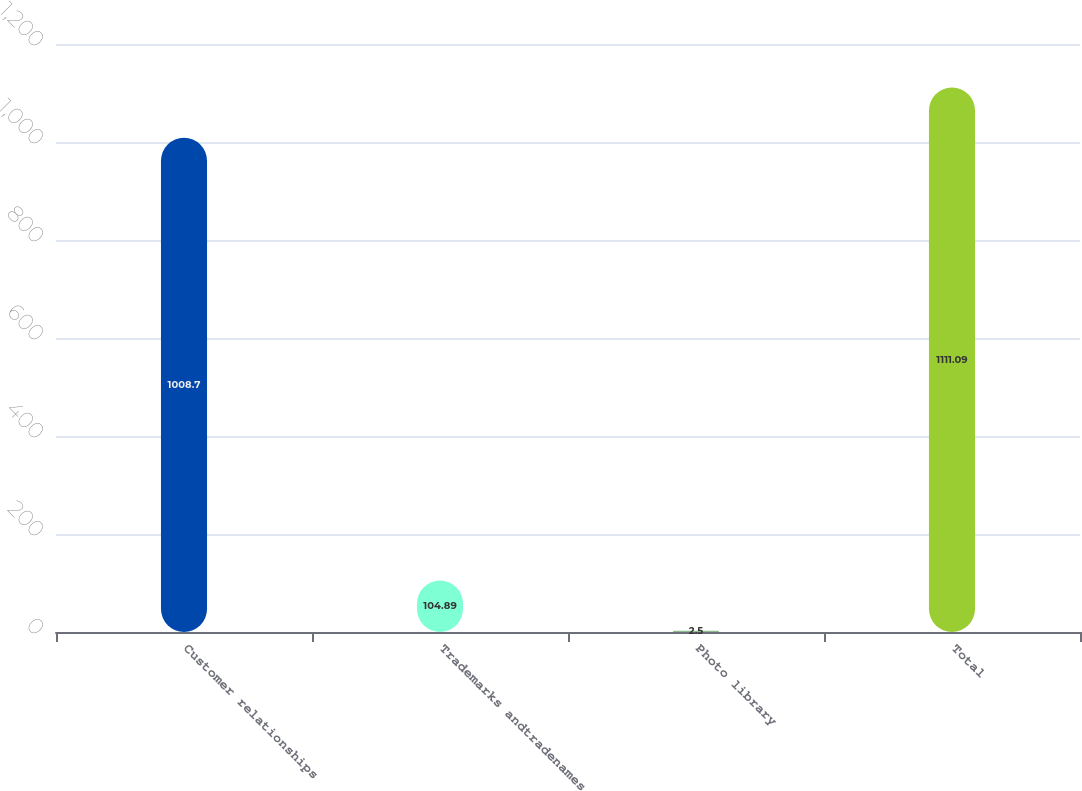<chart> <loc_0><loc_0><loc_500><loc_500><bar_chart><fcel>Customer relationships<fcel>Trademarks andtradenames<fcel>Photo library<fcel>Total<nl><fcel>1008.7<fcel>104.89<fcel>2.5<fcel>1111.09<nl></chart> 